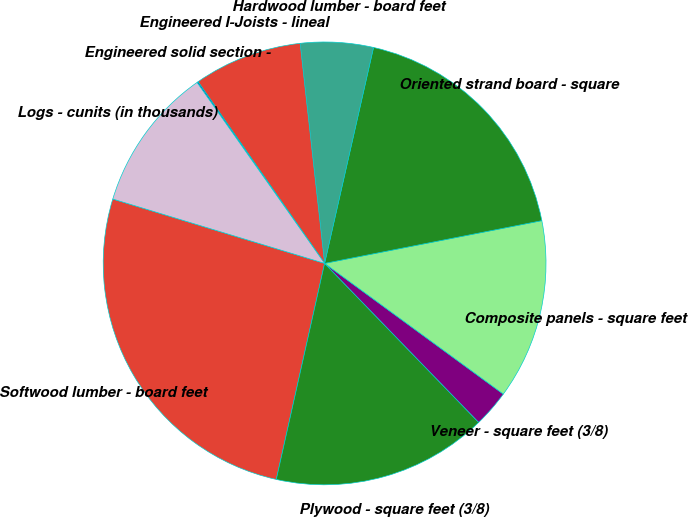Convert chart. <chart><loc_0><loc_0><loc_500><loc_500><pie_chart><fcel>Softwood lumber - board feet<fcel>Plywood - square feet (3/8)<fcel>Veneer - square feet (3/8)<fcel>Composite panels - square feet<fcel>Oriented strand board - square<fcel>Hardwood lumber - board feet<fcel>Engineered I-Joists - lineal<fcel>Engineered solid section -<fcel>Logs - cunits (in thousands)<nl><fcel>26.19%<fcel>15.75%<fcel>2.7%<fcel>13.14%<fcel>18.36%<fcel>5.31%<fcel>7.92%<fcel>0.09%<fcel>10.53%<nl></chart> 